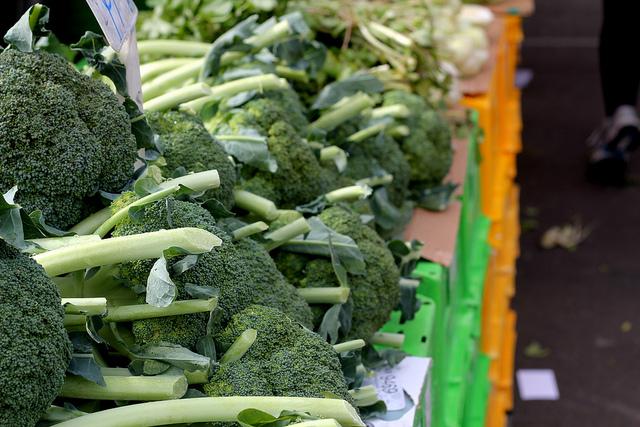Is the green stuff broccoli and spinach?
Give a very brief answer. Yes. Is it safe to eat this food product raw?
Answer briefly. Yes. What vegetable is closest to the camera?
Answer briefly. Broccoli. 